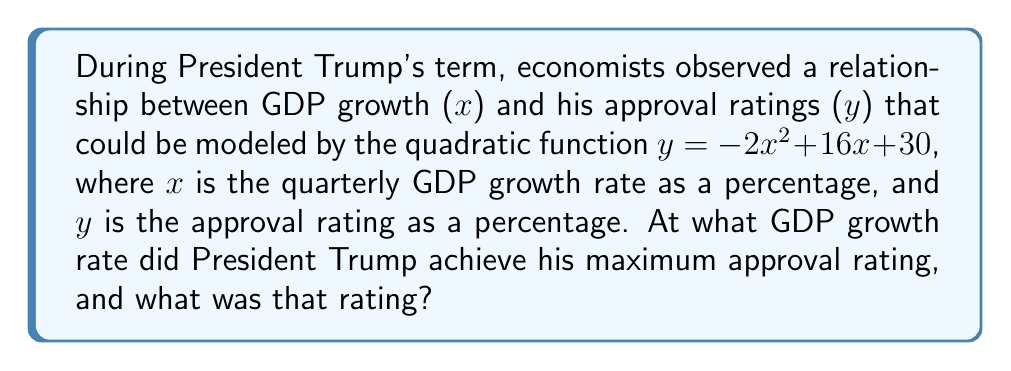What is the answer to this math problem? To solve this problem, we'll follow these steps:

1) The quadratic function is in the form $y = ax^2 + bx + c$, where $a = -2$, $b = 16$, and $c = 30$.

2) For a quadratic function, the x-coordinate of the vertex represents the value of x where y reaches its maximum (when $a < 0$) or minimum (when $a > 0$).

3) The formula for the x-coordinate of the vertex is $x = -\frac{b}{2a}$.

4) Substituting our values:
   $x = -\frac{16}{2(-2)} = -\frac{16}{-4} = 4$

5) This means the GDP growth rate that maximizes approval is 4%.

6) To find the maximum approval rating, we substitute x = 4 into the original equation:
   $y = -2(4)^2 + 16(4) + 30$
   $y = -2(16) + 64 + 30$
   $y = -32 + 64 + 30$
   $y = 62$

Therefore, the maximum approval rating is 62%.
Answer: GDP growth rate: 4%, Maximum approval rating: 62% 